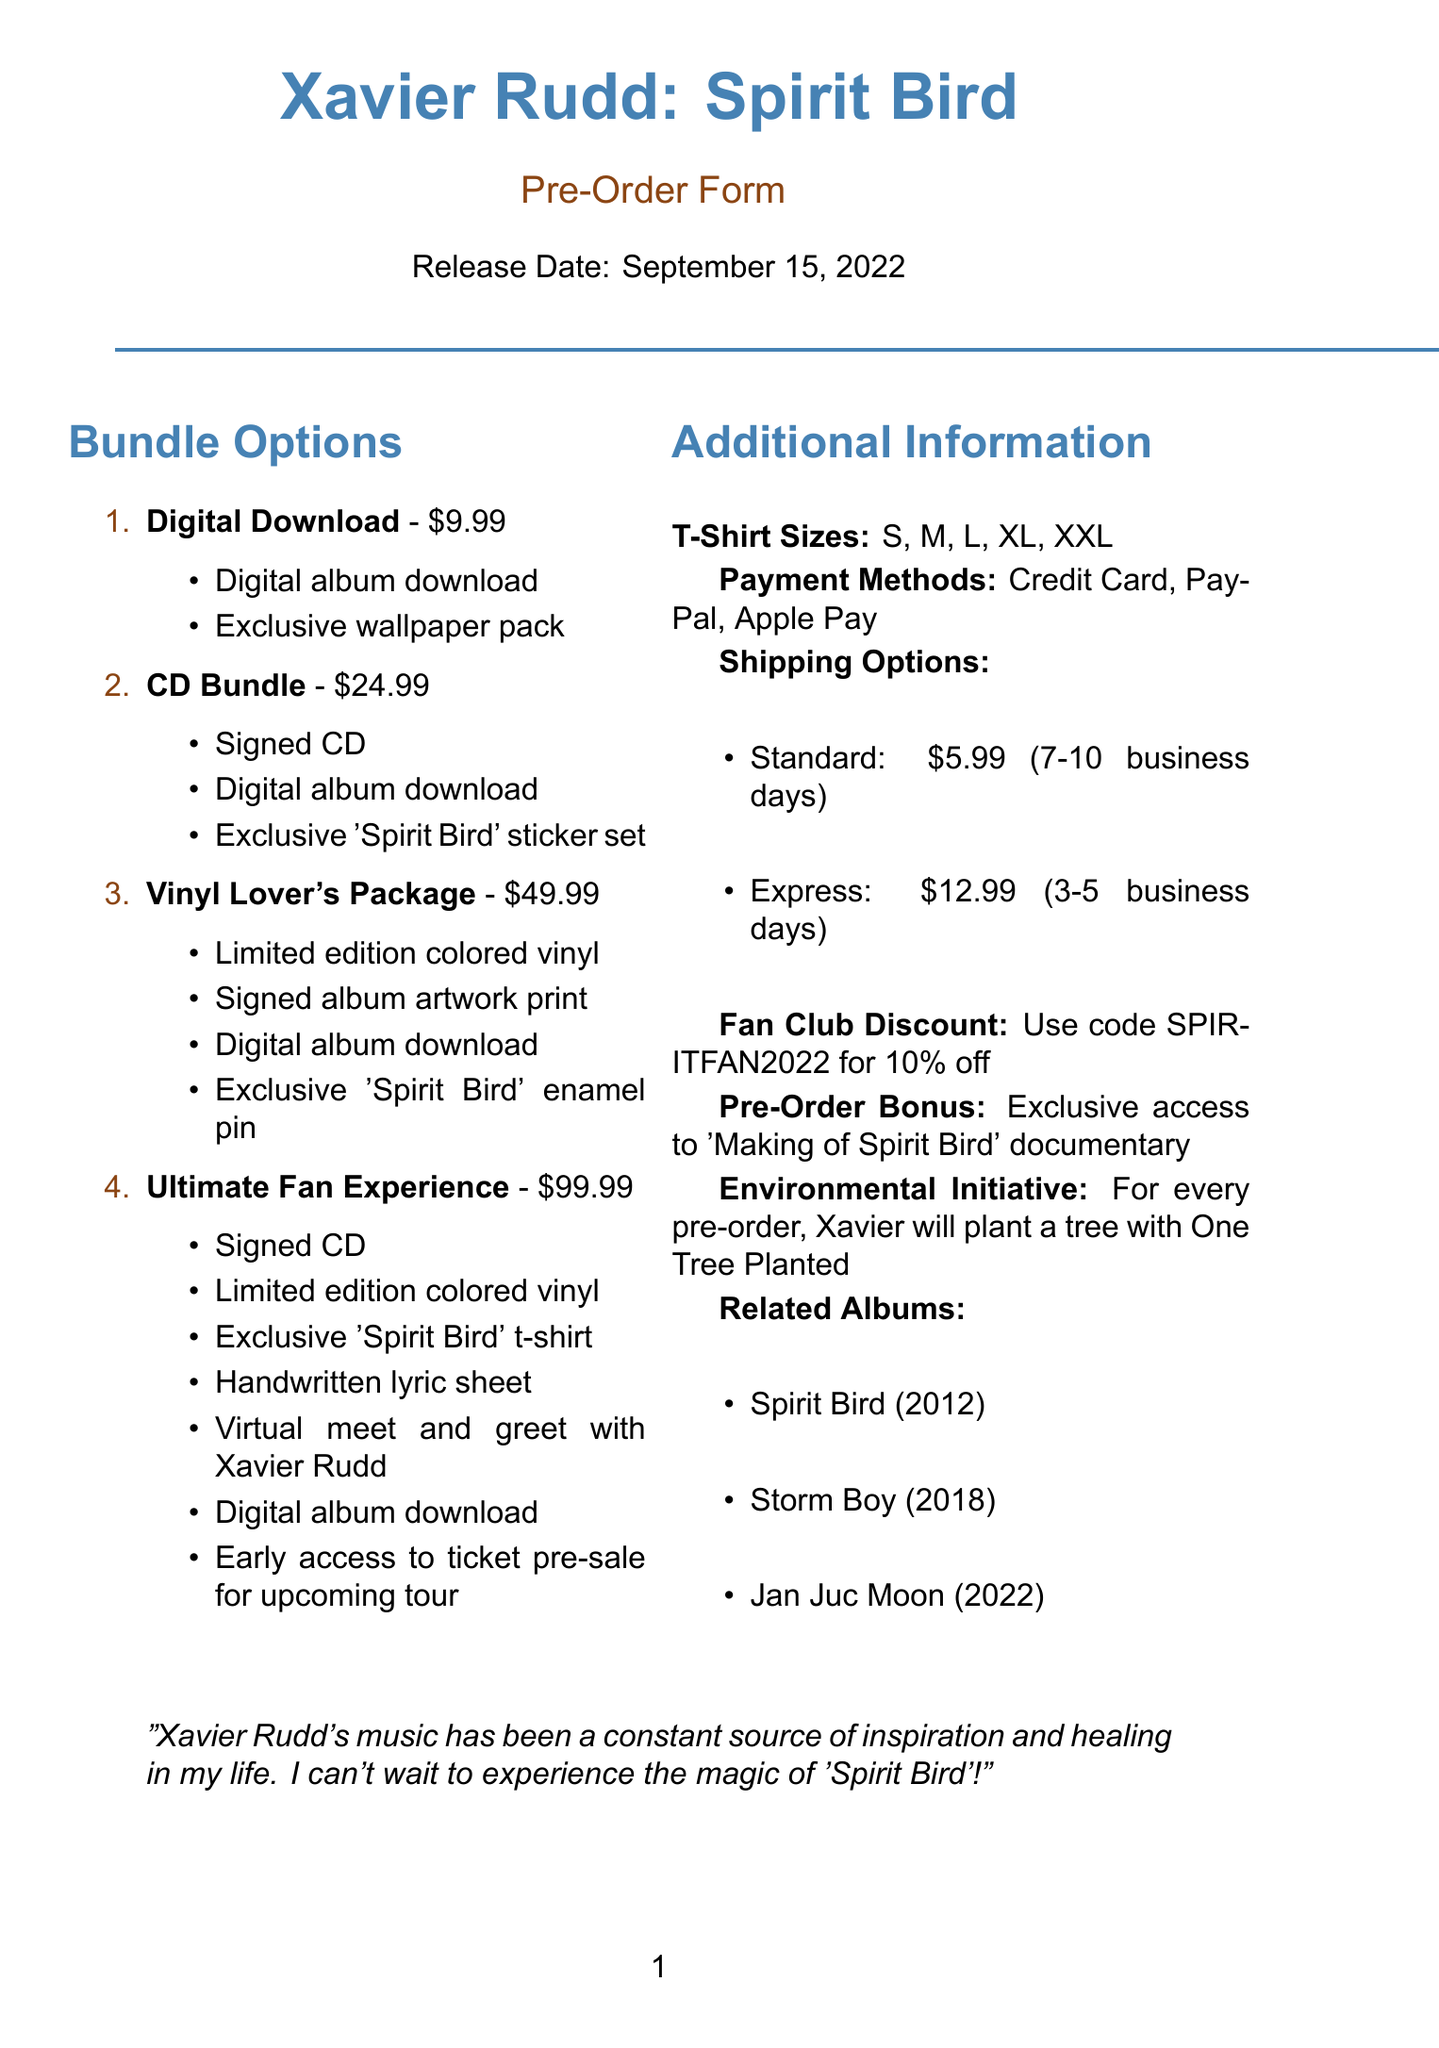What is the title of the album? The document specifies the album title at the beginning, which is "Spirit Bird".
Answer: Spirit Bird What is the release date of the album? The release date is mentioned in the document, which states it is September 15, 2022.
Answer: September 15, 2022 How much is the Ultimate Fan Experience bundle? The price of the Ultimate Fan Experience bundle is detailed in the options listed, which is $99.99.
Answer: $99.99 What discount code is available for fan club members? The document lists the discount code for fan club members, which is "SPIRITFAN2022".
Answer: SPIRITFAN2022 What is included in the Vinyl Lover's Package? This question requires identifying the items listed under the Vinyl Lover's Package option in the document.
Answer: Limited edition colored vinyl, Signed album artwork print, Digital album download, Exclusive 'Spirit Bird' enamel pin What is the estimated delivery time for Express Shipping? The estimated delivery time for Express Shipping is found in the shipping options section.
Answer: 3-5 business days How much is Standard Shipping? The shipping cost for Standard Shipping is mentioned clearly in the shipping options.
Answer: $5.99 What is the pre-order bonus mentioned in the document? The document clearly states that the pre-order bonus is exclusive access to a documentary.
Answer: Exclusive access to 'Making of Spirit Bird' documentary What environmental initiative is mentioned regarding pre-orders? The document highlights the environmental initiative associated with pre-orders, which involves planting a tree.
Answer: Plant a tree in partnership with One Tree Planted 